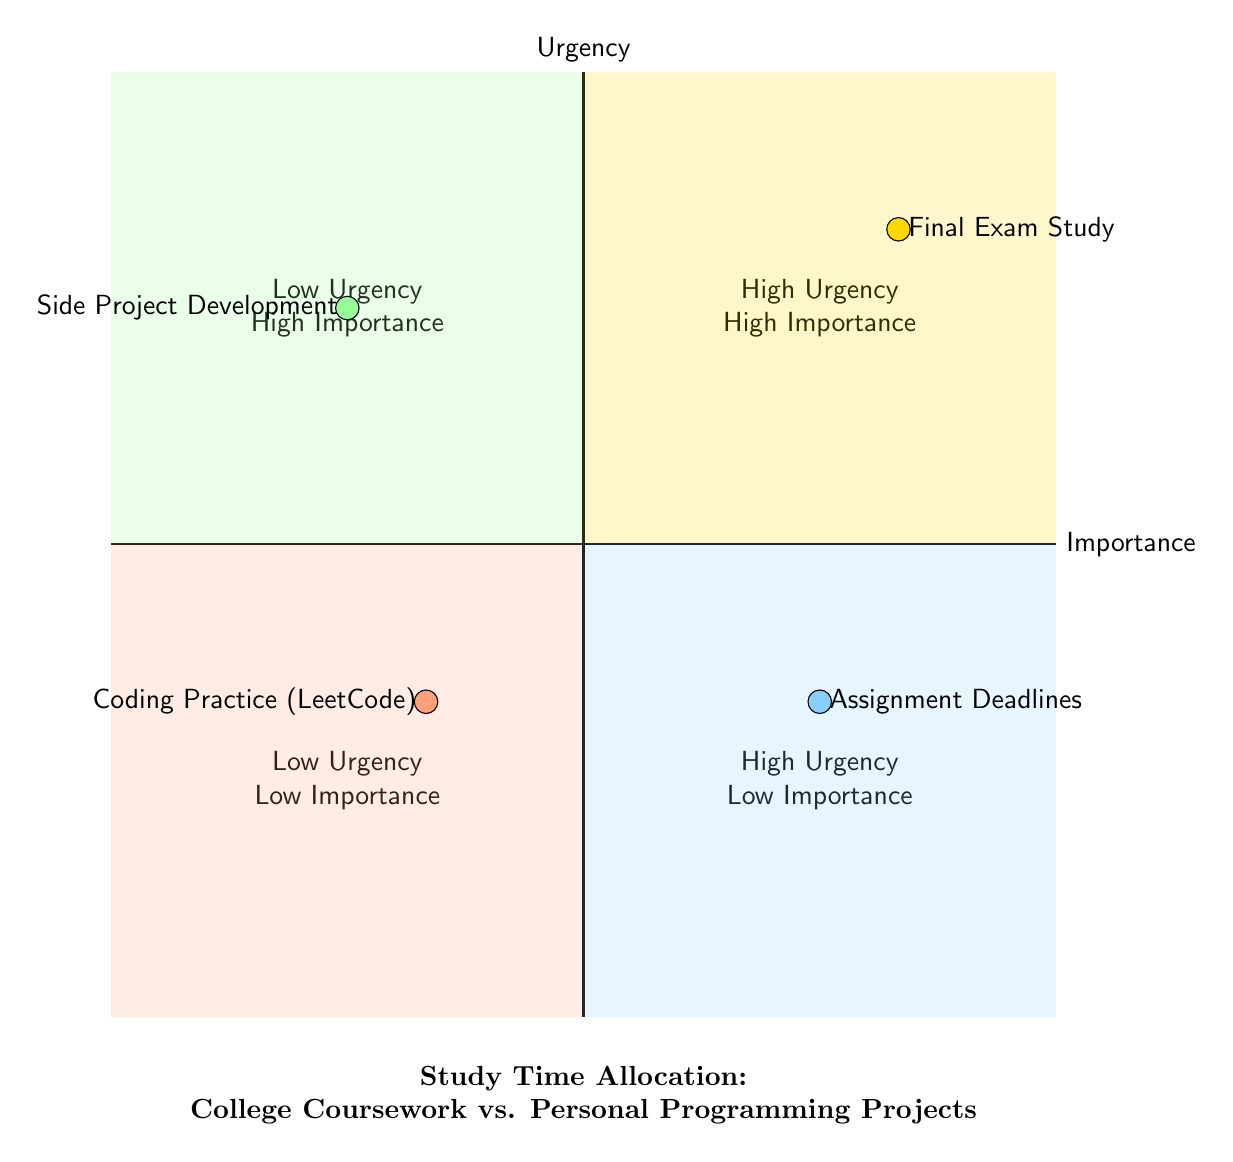What is located in the High Urgency and High Importance quadrant? In the diagram, the circle representing "Final Exam Study" is placed in the quadrant where both urgency and importance are high. This is deduced by finding the quadrant near the top right of the chart.
Answer: Final Exam Study Which task has Low Urgency and High Importance? The diagram shows "Side Project Development" placed in the Low Urgency and High Importance quadrant, located on the left side towards the top in the quadrant diagram.
Answer: Side Project Development How many items are placed in the Low Urgency and Medium Importance quadrant? By examining the bottom left quadrant, we can see that there are two items listed: "Assignment Deadlines" and "Coding Practice (LeetCode)", thus resulting in a total count of two.
Answer: 2 In which quadrant is Coding Practice (LeetCode) located? The position of "Coding Practice (LeetCode)" is in the Low Urgency and Low Importance quadrant, identifiable by its placement towards the bottom left of the diagram.
Answer: Low Urgency Low Importance What is the relationship between Final Exam Study and Assignment Deadlines in terms of urgency? Both "Final Exam Study" and "Assignment Deadlines" are placed in quadrants that correspond to high urgency, indicating they both require immediate attention despite differing importance levels.
Answer: Both are High Urgency Which task shows the highest satisfaction but the lowest time spent? By evaluating the tasks, "Hackathon Preparation" is clearly indicated as having high satisfaction while being positioned in the quadrant for Low time spent, distinguishing it from other tasks.
Answer: Hackathon Preparation What is the significance of the division of quadrants in the diagram? The quadrants are divided based on two main factors: urgency and importance. This division helps visually categorize tasks, allowing for clear prioritization strategies.
Answer: To categorize tasks How many total tasks are represented in the diagram? Counting all the tasks visible in the diagram reveals a total of six distinct items across various quadrants.
Answer: 6 